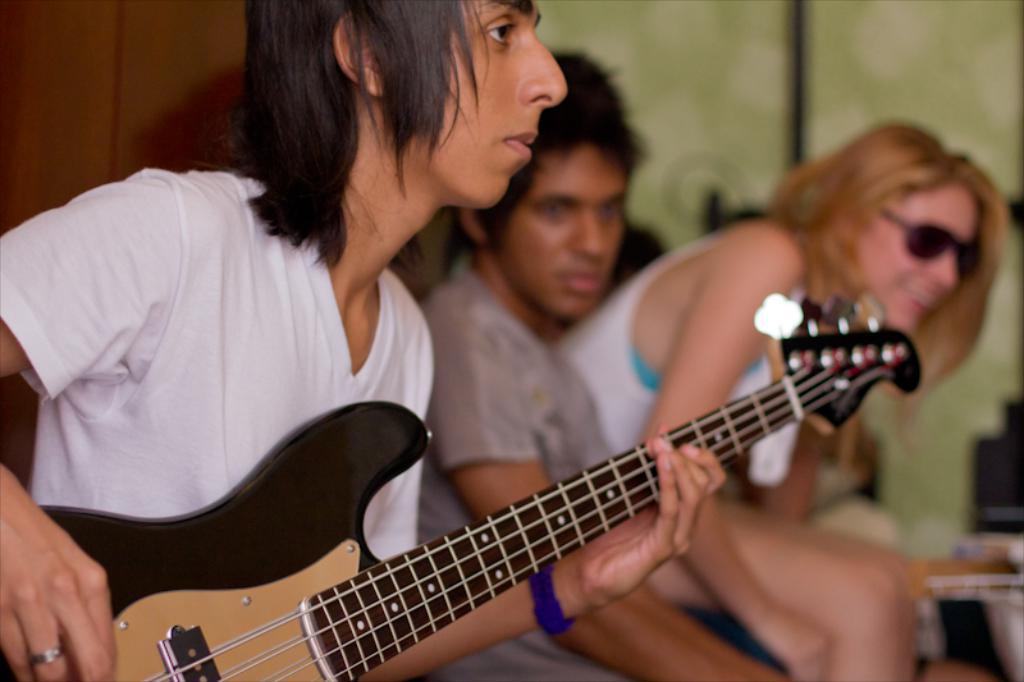Describe this image in one or two sentences. On the left there is a person who is playing a guitar. On the right there is a woman who is sitting on a chair. She looks very happy and she is wearing a goggles. On the middle of the picture On the right side person who is wearing a grey t-shirt. On the background we can see a green color. 